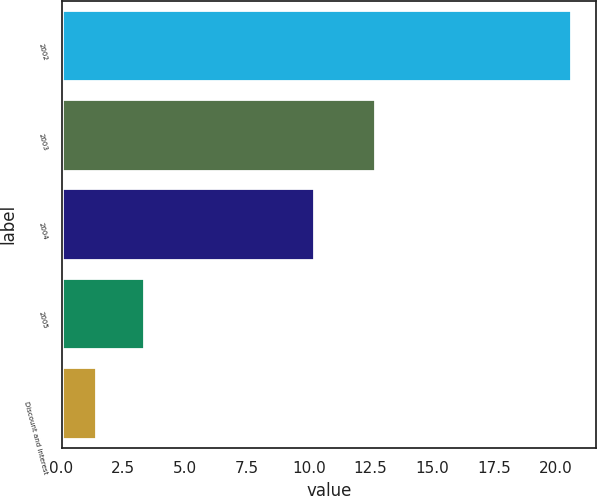Convert chart. <chart><loc_0><loc_0><loc_500><loc_500><bar_chart><fcel>2002<fcel>2003<fcel>2004<fcel>2005<fcel>Discount and interest<nl><fcel>20.6<fcel>12.7<fcel>10.2<fcel>3.32<fcel>1.4<nl></chart> 